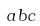Convert formula to latex. <formula><loc_0><loc_0><loc_500><loc_500>a b c</formula> 